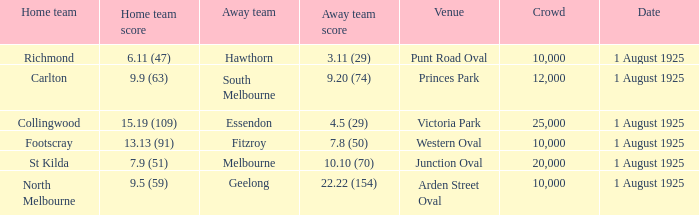Of matches that had a home team score of 13.13 (91), which one had the largest crowd? 10000.0. 